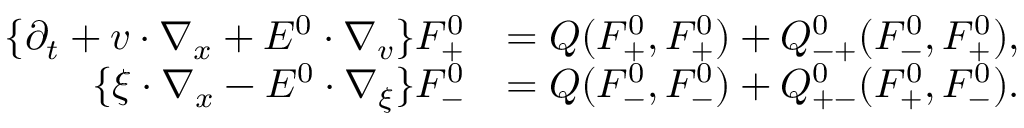<formula> <loc_0><loc_0><loc_500><loc_500>\begin{array} { r l } { \{ \partial _ { t } + v \cdot \nabla _ { x } + E ^ { 0 } \cdot \nabla _ { v } \} F _ { + } ^ { 0 } } & { = Q ( F _ { + } ^ { 0 } , F _ { + } ^ { 0 } ) + Q _ { - + } ^ { 0 } ( F _ { - } ^ { 0 } , F _ { + } ^ { 0 } ) , } \\ { \{ \xi \cdot \nabla _ { x } - E ^ { 0 } \cdot \nabla _ { \xi } \} F _ { - } ^ { 0 } } & { = Q ( F _ { - } ^ { 0 } , F _ { - } ^ { 0 } ) + Q _ { + - } ^ { 0 } ( F _ { + } ^ { 0 } , F _ { - } ^ { 0 } ) . } \end{array}</formula> 